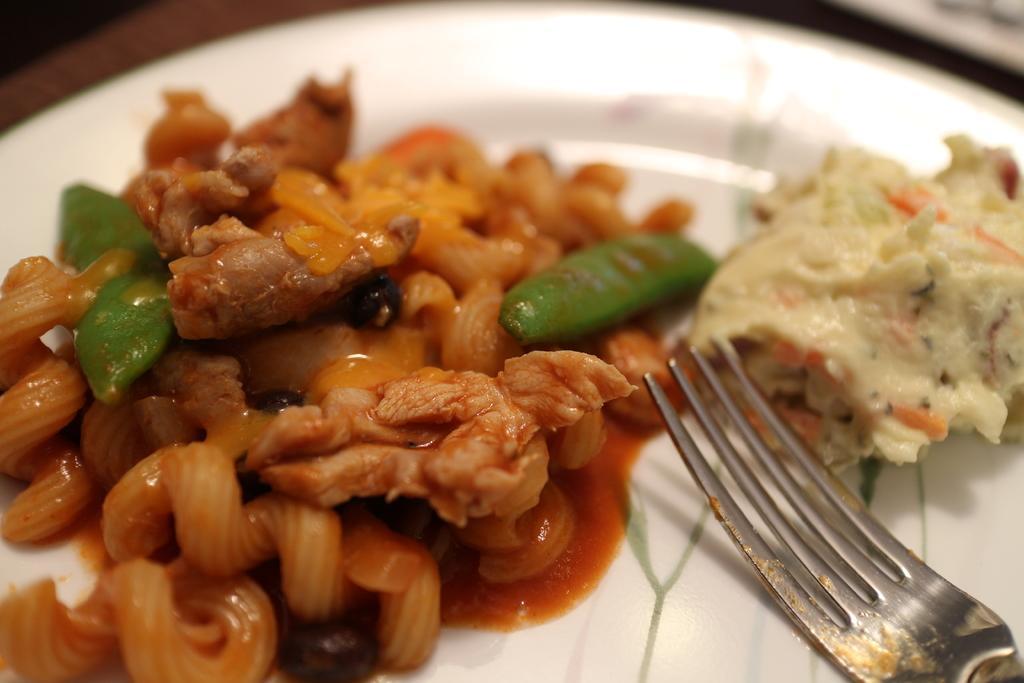Could you give a brief overview of what you see in this image? In this image I can see a fork and food item on a white color plate. 